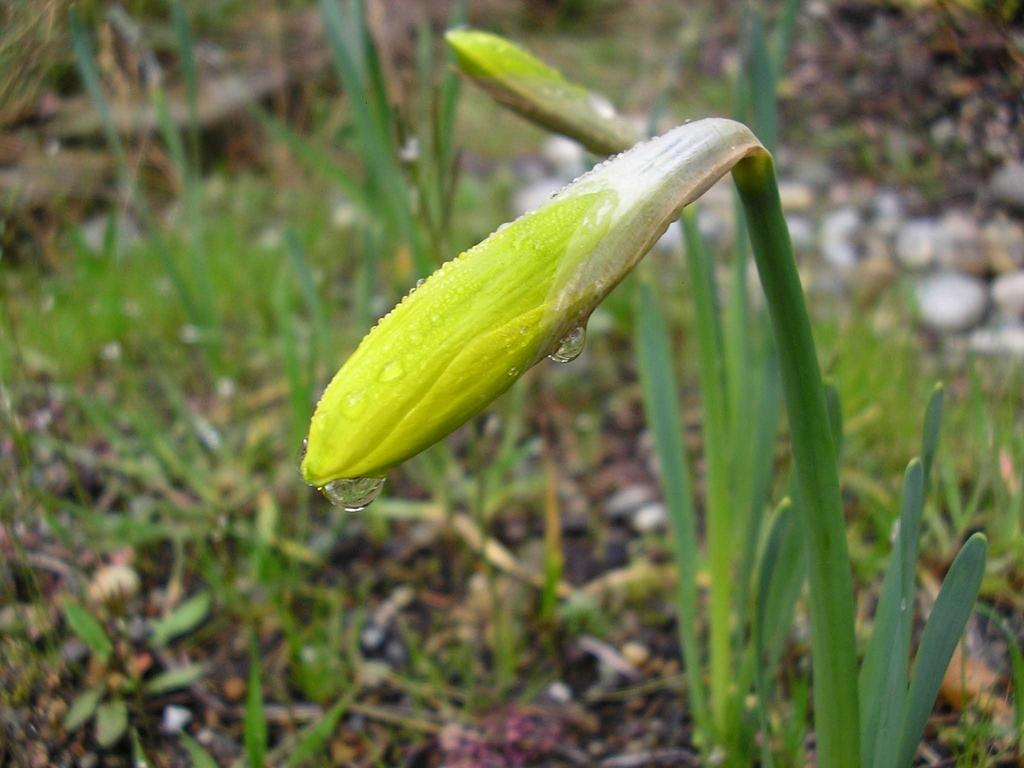What is located in the foreground of the image? There is a plant in the foreground of the image. What can be observed on the plant? There are water droplets on the plant. What type of vegetation is visible at the bottom of the image? There is grass at the bottom of the image. What other objects can be seen at the bottom of the image? There are small stones and scrap at the bottom of the image. What type of wine is being served in the image? There is no wine present in the image; it features a plant with water droplets and other objects at the bottom. What riddle can be solved by looking at the image? There is no riddle associated with the image, as it simply depicts a plant and other objects. 